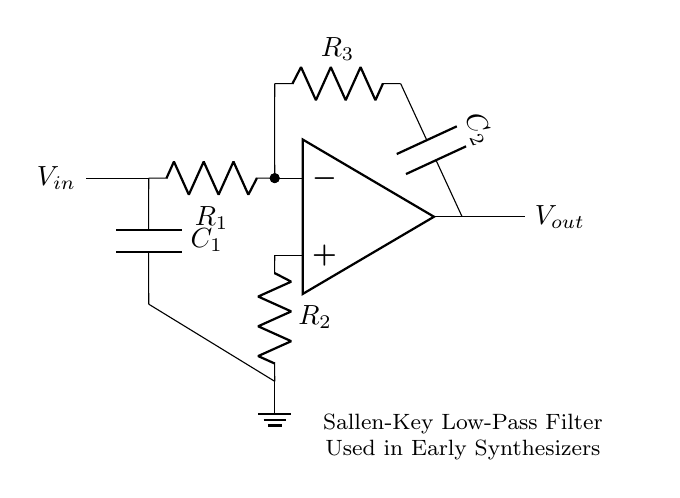What is the input voltage connection labeled as? The circuit diagram indicates the input voltage connection by the label "V_in" to the left of the input resistor R1. This label signifies where the input signal is applied in the circuit.
Answer: V_in What type of filter is represented in this circuit? The circuit is labeled as a "Sallen-Key Low-Pass Filter" at the bottom. This indicates that the function of the circuit is to allow low-frequency signals to pass while attenuating high-frequency signals.
Answer: Low-Pass Filter How many resistors are in the circuit diagram? Upon examining the diagram, three resistors are shown: R1, R2, and R3. Each one is distinctly labeled and is part of the feedback and input stages of the amplifier configuration.
Answer: Three What is the ground reference marked as in the circuit? The ground reference point is marked by a symbol labeled "ground" in the diagram. This point serves as the common return path for electrical current and reference potential for the circuit.
Answer: Ground What components are involved in the feedback loop? The feedback loop consists of the operational amplifier, resistor R3, and capacitor C2. Together, these components form part of the feedback that shapes the filter characteristics, such as gain and frequency response.
Answer: R3, C2 What is the value of R1 if it is needed for critical damping in this filter topology? R1 is not given a numerical value in the circuit diagram data provided, but typically, for critical damping, the value can vary depending on the desired cutoff frequency and the specific characteristics of the active filter design.
Answer: Not specified Which component defines the cutoff frequency of the filter? The cutoff frequency of the filter is determined by resistors R1 and R2 in combination with capacitors C1 and C2. Therefore, these components play a pivotal role in setting the extent of frequency response in the filter design.
Answer: R1, R2, C1, C2 